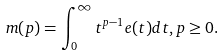Convert formula to latex. <formula><loc_0><loc_0><loc_500><loc_500>m ( p ) = \int _ { 0 } ^ { \infty } t ^ { p - 1 } e ( t ) d t , p \geq 0 .</formula> 